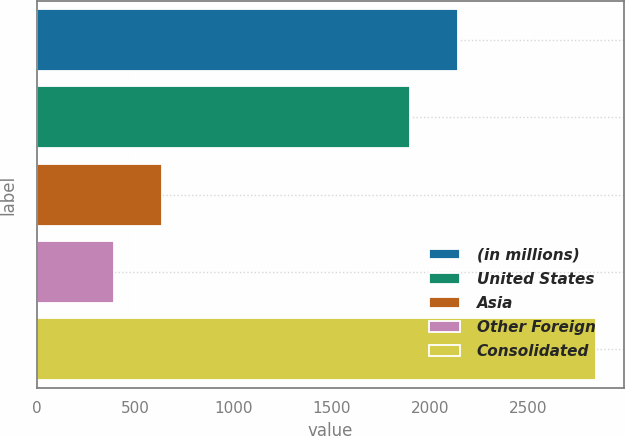Convert chart. <chart><loc_0><loc_0><loc_500><loc_500><bar_chart><fcel>(in millions)<fcel>United States<fcel>Asia<fcel>Other Foreign<fcel>Consolidated<nl><fcel>2141.3<fcel>1896<fcel>637.3<fcel>392<fcel>2845<nl></chart> 